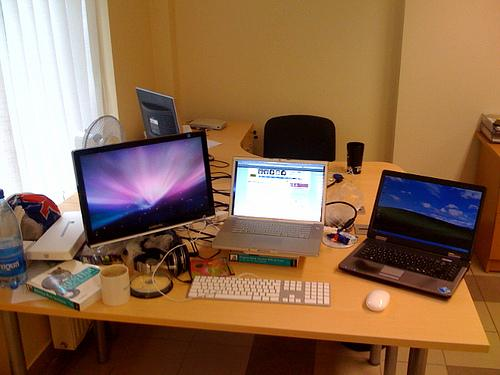What is the white rounded object on the right?

Choices:
A) mouse
B) router
C) case
D) soap mouse 